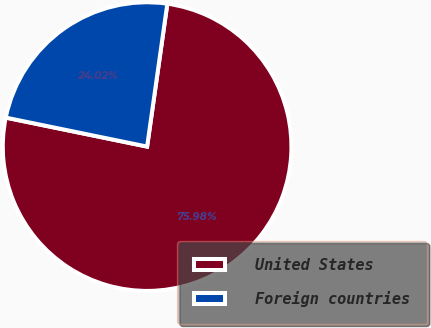<chart> <loc_0><loc_0><loc_500><loc_500><pie_chart><fcel>United States<fcel>Foreign countries<nl><fcel>75.98%<fcel>24.02%<nl></chart> 